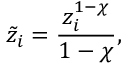<formula> <loc_0><loc_0><loc_500><loc_500>\tilde { z } _ { i } = \frac { z _ { i } ^ { 1 - \chi } } { 1 - \chi } ,</formula> 